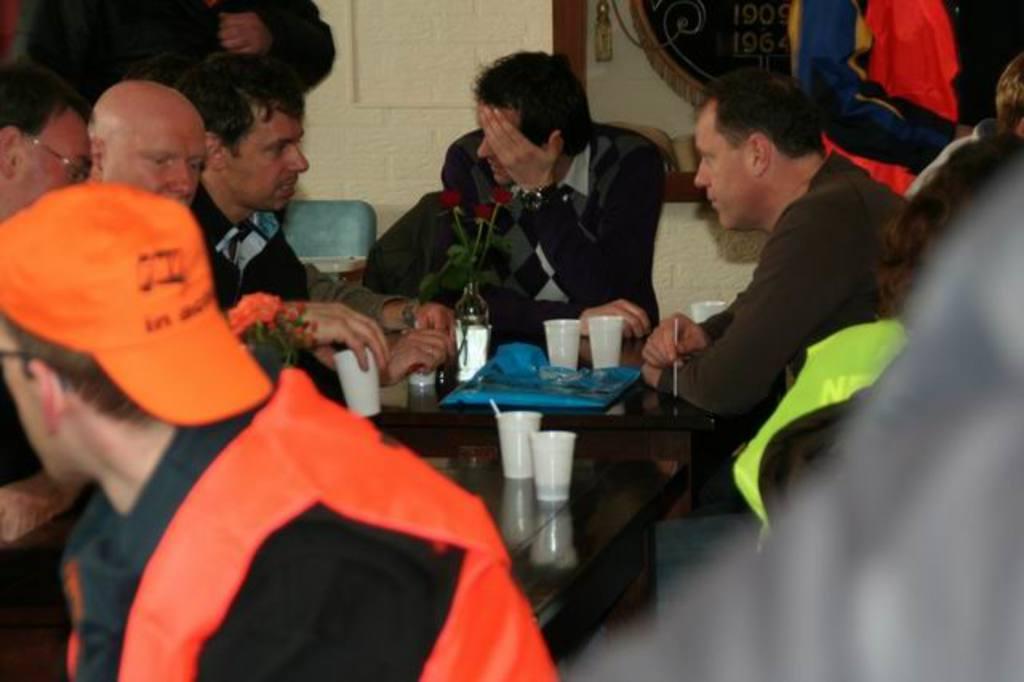How would you summarize this image in a sentence or two? In this image we can see a group of people are sitting, in front here is the table, here is the flower vase, here are the roses, here are the glasses, and some objects on it, here is the wall. 